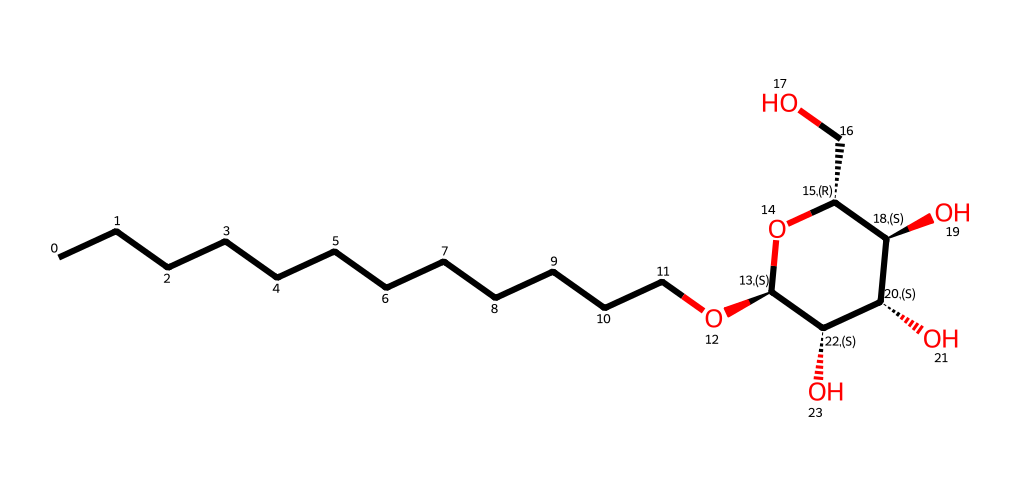What is the longest carbon chain in this molecule? The longest carbon chain is identified by counting the number of consecutive carbon atoms connected directly by single bonds. In the provided SMILES, there are twelve continuous carbon atoms before branching at the oxygen.
Answer: twelve How many hydroxyl (–OH) groups are present? The hydroxyl groups can be found by identifying the parts of the molecule that contain the –OH functional group. In this structure, there are three –OH groups attached to the sugar units indicated by the structure.
Answer: three What type of surfactant is represented by this molecule? Based on the structure, which includes a long hydrophobic alkyl chain and a hydrophilic sugar moiety, this molecule is classified as a non-ionic surfactant, which is typical for alkyl polyglucosides.
Answer: non-ionic What is the total number of oxygen atoms in this molecule? To find the total number of oxygen atoms, we count each occurrence of oxygen in the SMILES representation. Here, there are four oxygen atoms present.
Answer: four What structural feature allows this surfactant to be eco-friendly? The eco-friendliness of this surfactant mainly comes from its natural, renewable source (glucose) and the absence of harmful ingredients common in synthetic surfactants. The molecular structure indicates that it is biodegradable.
Answer: biodegradable How many stereocenters are present in the sugar part of this molecule? Stereocenters can be identified by looking for carbon atoms that are bonded to four different groups. In the sugar ring of this molecule, there are three stereocenters.
Answer: three 